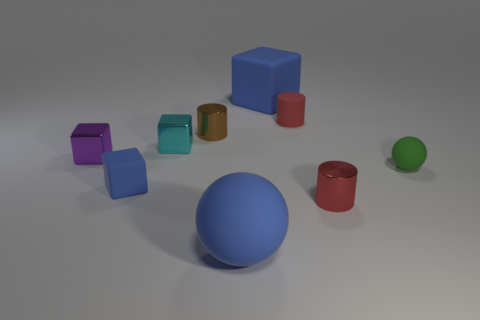Could you describe the colors of the blocks and balls and how they are placed relative to each other? Certainly! In the image, we see an assortment of blocks and balls with varying colors and finishes. To the left, there are two larger blocks, one blue and one red, both with a smooth and matte finish. Clustered together toward the center are four smaller blocks—two are shades of blue, one is violet, and one has a metallic finish that reflects cyan. On the right side, we have two balls, the larger one being a vivid blue and the smaller a bright green; they are placed apart from each other. A small red cylindrical object is also visible, situated close to the green ball. 